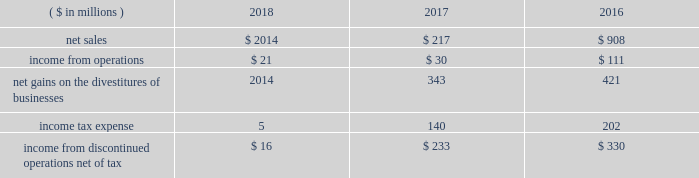2018 ppg annual report and form 10-k 59 other acquisitions in 2018 , 2017 , and 2016 , the company completed several smaller business acquisitions .
The total consideration paid for these acquisitions , net of cash acquired , debt assumed and other post closing adjustments , was $ 108 million , $ 74 million and $ 43 million , respectively .
In january 2018 , ppg acquired procoatings , a leading architectural paint and coatings wholesaler located in the netherlands .
Procoatings , established in 2001 , distributes a large portfolio of well-known professional paint brands through its network of 23 multi-brand stores .
The company employs nearly 100 people .
The results of this business since the date of acquisition have been reported within the architectural coatings americas and asia pacific business within the performance coatings reportable segment .
In january 2017 , ppg acquired certain assets of automotive refinish coatings company futian xinshi ( 201cfutian 201d ) , based in the guangdong province of china .
Futian distributes its products in china through a network of more than 200 distributors .
In january 2017 , ppg completed the acquisition of deutek s.a. , a leading romanian paint and architectural coatings manufacturer , from the emerging europe accession fund .
Deutek , established in 1993 , manufactures and markets a large portfolio of well-known professional and consumer paint brands , including oskar and danke! .
The company 2019s products are sold in more than 120 do-it-yourself stores and 3500 independent retail outlets in romania .
Divestitures glass segment in 2017 , ppg completed a multi-year strategic shift in the company's business portfolio , resulting in the exit of all glass operations which consisted of the global fiber glass business , ppg's ownership interest in two asian fiber glass joint ventures and the flat glass business .
Accordingly , the results of operations , including the gains on the divestitures , and cash flows have been recast as discontinued operations for all periods presented .
Ppg now has two reportable business segments .
The net sales and income from discontinued operations related to the former glass segment for the three years ended december 31 , 2018 , 2017 , and 2016 were as follows: .
During 2018 , ppg released $ 13 million of previously recorded accruals and contingencies established in conjunction with the divestitures of businesses within the former glass segment as a result of completed actions , new information and updated estimates .
Also during 2018 , ppg made a final payment of $ 20 million to vitro s.a.b .
De c.v related to the transfer of certain pension obligations upon the sale of the former flat glass business .
North american fiber glass business on september 1 , 2017 , ppg completed the sale of its north american fiber glass business to nippon electric glass co .
Ltd .
( 201cneg 201d ) .
Cash proceeds from the sale were $ 541 million , resulting in a pre-tax gain of $ 343 million , net of certain accruals and contingencies established in conjunction with the divestiture .
Ppg 2019s fiber glass operations included manufacturing facilities in chester , south carolina , and lexington and shelby , north carolina ; and administrative and research-and-development operations in shelby and in harmar , pennsylvania , near pittsburgh .
The business , which employed more than 1000 people and had net sales of approximately $ 350 million in 2016 , supplies the transportation , energy , infrastructure and consumer markets .
Flat glass business in october 2016 , ppg completed the sale of its flat glass manufacturing and glass coatings operations to vitro s.a.b .
De c.v .
Ppg received approximately $ 740 million in cash proceeds and recorded a pre-tax gain of $ 421 million on the sale .
Under the terms of the agreement , ppg divested its entire flat glass manufacturing and glass coatings operations , including production sites located in fresno , california ; salem , oregon ; carlisle , pennsylvania ; and wichita falls , texas ; four distribution/fabrication facilities located across canada ; and a research-and-development center located in harmar , pennsylvania .
Ppg 2019s flat glass business included approximately 1200 employees .
The business manufactures glass that is fabricated into products used primarily in commercial and residential construction .
Notes to the consolidated financial statements .
What was operating income return on sales on the discontinued glass segment in 2017? 
Computations: (30 / 217)
Answer: 0.13825. 